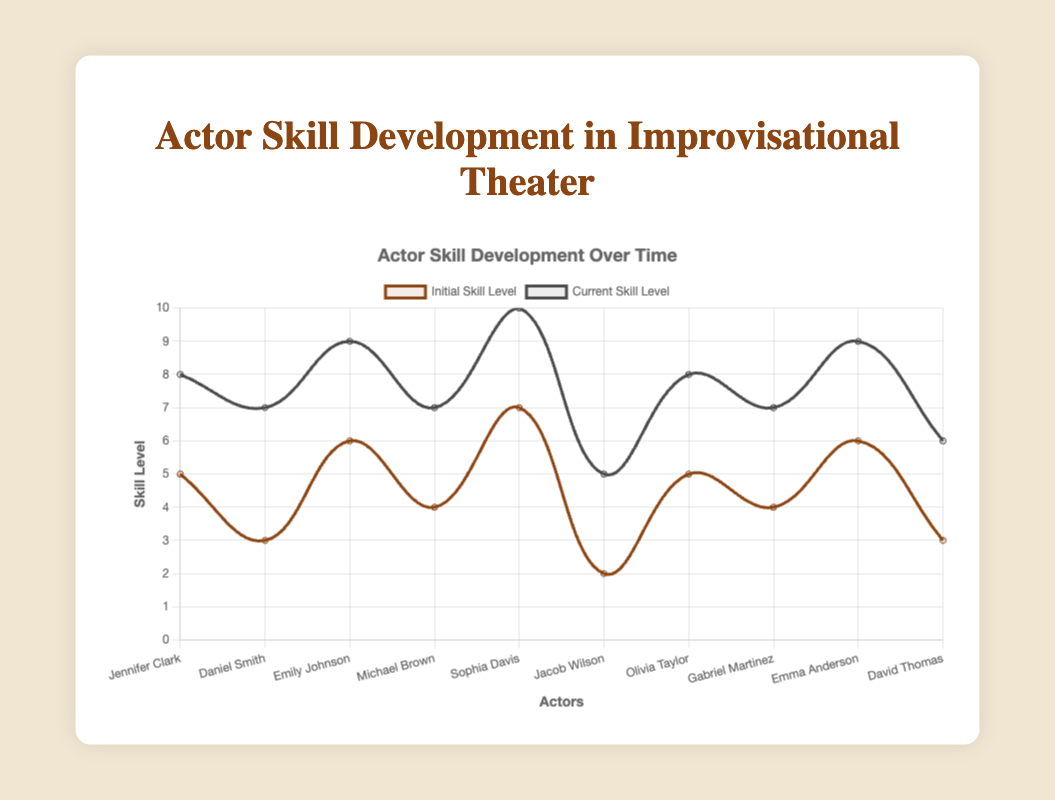Which actor started with the highest initial skill level? By observing the initial skill levels on the chart, we can see that Sophia Davis started with the highest initial skill level of 7.
Answer: Sophia Davis Which actor showed the greatest improvement in skill level over time? To determine the greatest improvement, calculate the difference between the current skill level and the initial skill level for each actor. The greatest improvement is shown by Daniel Smith, who improved by 4 levels (7-3=4).
Answer: Daniel Smith How many actors had an initial skill level of 4 or below? By examining the initial skill levels, we can see that Michael Brown (4), Gabriel Martinez (4), Daniel Smith (3), David Thomas (3), and Jacob Wilson (2) had initial skill levels of 4 or below. This accounts for 5 actors.
Answer: 5 Who attended the most improvisational workshops? By referring to the data associated with each actor, Sophia Davis attended the most improvisational workshops, with a total of 20 workshops.
Answer: Sophia Davis What is the average current skill level of the actors? Sum the current skill levels of all actors (8 + 7 + 9 + 7 + 10 + 5 + 8 + 7 + 9 + 6 = 76) and divide by the number of actors (10). The average current skill level is 76/10 = 7.6.
Answer: 7.6 Which actor has the smallest difference between their initial and current skill level? Calculate the difference between the initial and current skill levels for each actor. Jennifer Clark, Olivia Taylor, and Michael Brown each have a difference of 3 between their initial and current skill levels, which is the smallest difference.
Answer: Jennifer Clark, Olivia Taylor, Michael Brown Compare the current skill levels of the actors who have been in the troupe for 2 years and identify the highest and lowest. The actors who have been in the troupe for 2 years are Jennifer Clark (8), Michael Brown (7), Gabriel Martinez (7), and David Thomas (6). The highest current skill level among them is Jennifer Clark (8) and the lowest is David Thomas (6).
Answer: Highest: Jennifer Clark, Lowest: David Thomas 